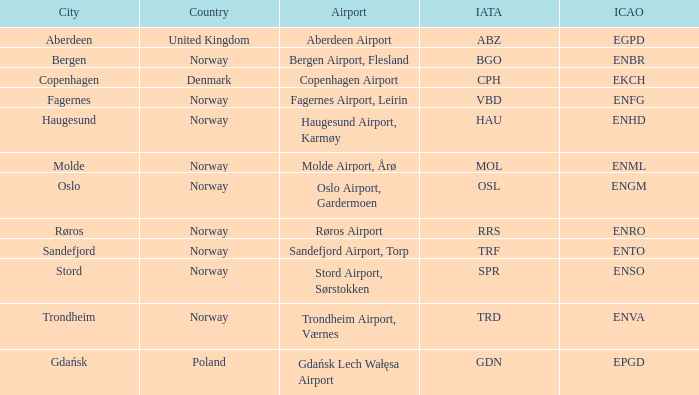What is the iata designation for sandefjord in norway? TRF. 